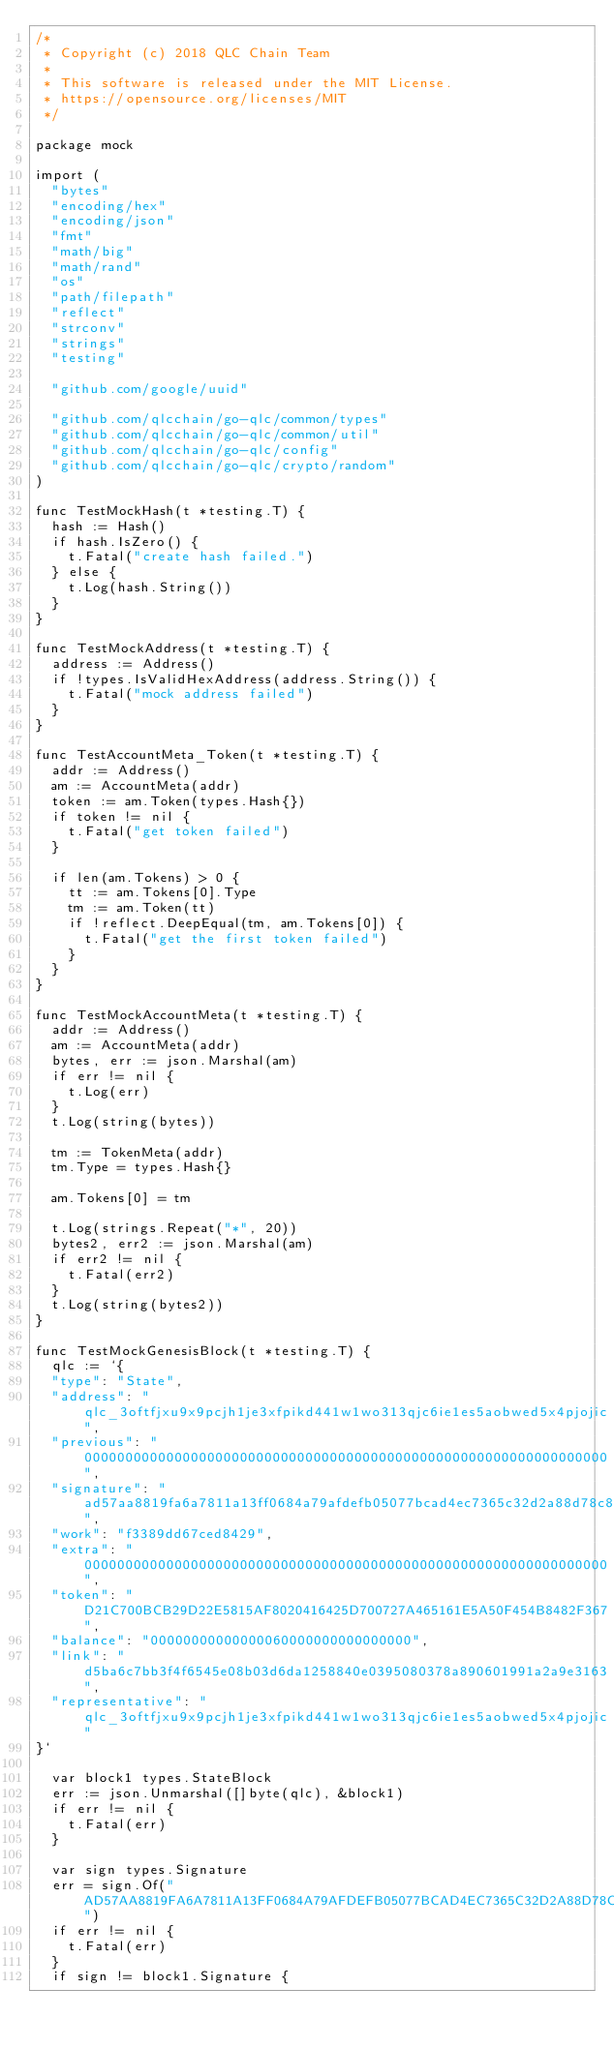Convert code to text. <code><loc_0><loc_0><loc_500><loc_500><_Go_>/*
 * Copyright (c) 2018 QLC Chain Team
 *
 * This software is released under the MIT License.
 * https://opensource.org/licenses/MIT
 */

package mock

import (
	"bytes"
	"encoding/hex"
	"encoding/json"
	"fmt"
	"math/big"
	"math/rand"
	"os"
	"path/filepath"
	"reflect"
	"strconv"
	"strings"
	"testing"

	"github.com/google/uuid"

	"github.com/qlcchain/go-qlc/common/types"
	"github.com/qlcchain/go-qlc/common/util"
	"github.com/qlcchain/go-qlc/config"
	"github.com/qlcchain/go-qlc/crypto/random"
)

func TestMockHash(t *testing.T) {
	hash := Hash()
	if hash.IsZero() {
		t.Fatal("create hash failed.")
	} else {
		t.Log(hash.String())
	}
}

func TestMockAddress(t *testing.T) {
	address := Address()
	if !types.IsValidHexAddress(address.String()) {
		t.Fatal("mock address failed")
	}
}

func TestAccountMeta_Token(t *testing.T) {
	addr := Address()
	am := AccountMeta(addr)
	token := am.Token(types.Hash{})
	if token != nil {
		t.Fatal("get token failed")
	}

	if len(am.Tokens) > 0 {
		tt := am.Tokens[0].Type
		tm := am.Token(tt)
		if !reflect.DeepEqual(tm, am.Tokens[0]) {
			t.Fatal("get the first token failed")
		}
	}
}

func TestMockAccountMeta(t *testing.T) {
	addr := Address()
	am := AccountMeta(addr)
	bytes, err := json.Marshal(am)
	if err != nil {
		t.Log(err)
	}
	t.Log(string(bytes))

	tm := TokenMeta(addr)
	tm.Type = types.Hash{}

	am.Tokens[0] = tm

	t.Log(strings.Repeat("*", 20))
	bytes2, err2 := json.Marshal(am)
	if err2 != nil {
		t.Fatal(err2)
	}
	t.Log(string(bytes2))
}

func TestMockGenesisBlock(t *testing.T) {
	qlc := `{
  "type": "State",
  "address": "qlc_3oftfjxu9x9pcjh1je3xfpikd441w1wo313qjc6ie1es5aobwed5x4pjojic",
  "previous": "0000000000000000000000000000000000000000000000000000000000000000",
  "signature": "ad57aa8819fa6a7811a13ff0684a79afdefb05077bcad4ec7365c32d2a88d78c8c7c54717b40c0888a0692d05bf3771df6d16a1f24ae612172922bbd4d93370f",
  "work": "f3389dd67ced8429",
  "extra": "0000000000000000000000000000000000000000000000000000000000000000",
  "token": "D21C700BCB29D22E5815AF8020416425D700727A465161E5A50F454B8482F367",
  "balance": "00000000000000060000000000000000",
  "link": "d5ba6c7bb3f4f6545e08b03d6da1258840e0395080378a890601991a2a9e3163",
  "representative": "qlc_3oftfjxu9x9pcjh1je3xfpikd441w1wo313qjc6ie1es5aobwed5x4pjojic"
}`

	var block1 types.StateBlock
	err := json.Unmarshal([]byte(qlc), &block1)
	if err != nil {
		t.Fatal(err)
	}

	var sign types.Signature
	err = sign.Of("AD57AA8819FA6A7811A13FF0684A79AFDEFB05077BCAD4EC7365C32D2A88D78C8C7C54717B40C0888A0692D05BF3771DF6D16A1F24AE612172922BBD4D93370F")
	if err != nil {
		t.Fatal(err)
	}
	if sign != block1.Signature {</code> 